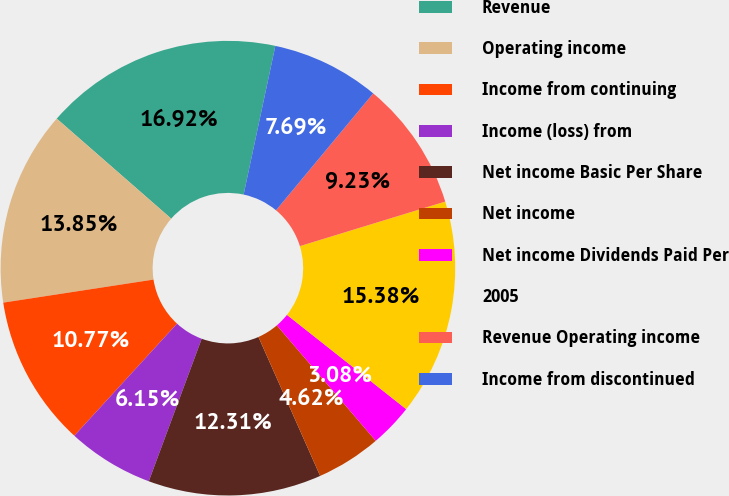Convert chart. <chart><loc_0><loc_0><loc_500><loc_500><pie_chart><fcel>Revenue<fcel>Operating income<fcel>Income from continuing<fcel>Income (loss) from<fcel>Net income Basic Per Share<fcel>Net income<fcel>Net income Dividends Paid Per<fcel>2005<fcel>Revenue Operating income<fcel>Income from discontinued<nl><fcel>16.92%<fcel>13.85%<fcel>10.77%<fcel>6.15%<fcel>12.31%<fcel>4.62%<fcel>3.08%<fcel>15.38%<fcel>9.23%<fcel>7.69%<nl></chart> 